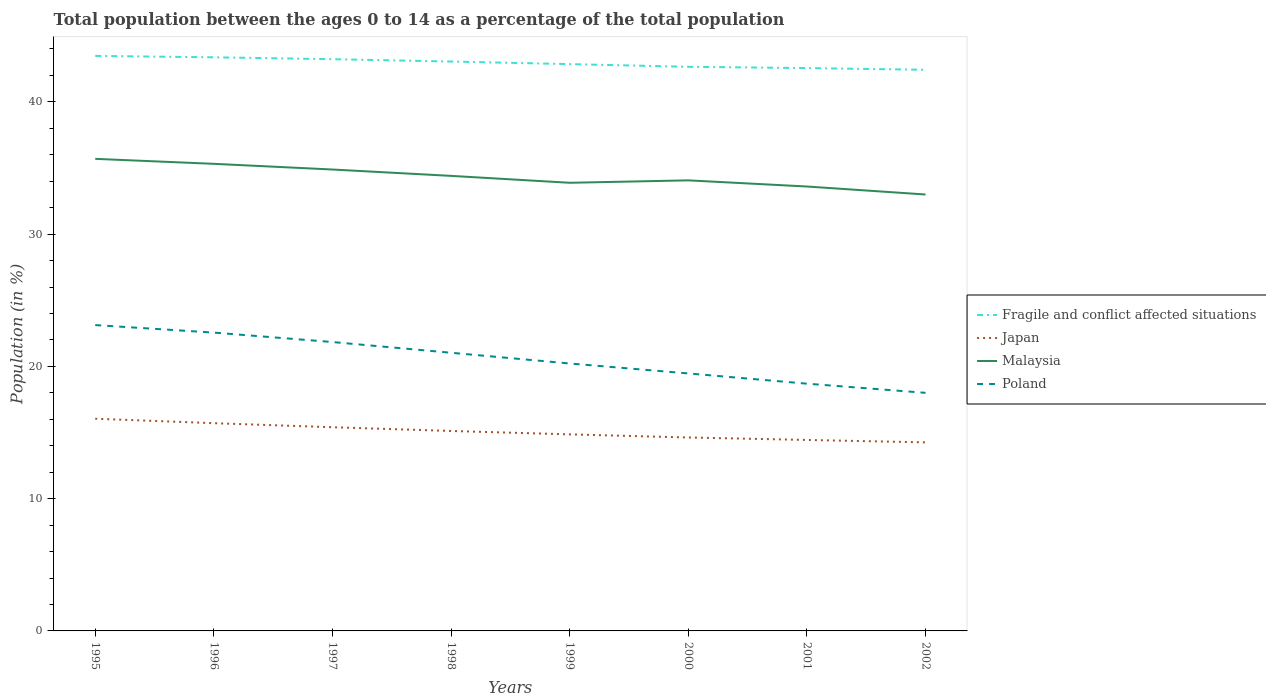How many different coloured lines are there?
Your answer should be compact. 4. Is the number of lines equal to the number of legend labels?
Provide a succinct answer. Yes. Across all years, what is the maximum percentage of the population ages 0 to 14 in Malaysia?
Make the answer very short. 32.99. In which year was the percentage of the population ages 0 to 14 in Japan maximum?
Your response must be concise. 2002. What is the total percentage of the population ages 0 to 14 in Japan in the graph?
Give a very brief answer. 1.79. What is the difference between the highest and the second highest percentage of the population ages 0 to 14 in Poland?
Your answer should be very brief. 5.12. What is the difference between the highest and the lowest percentage of the population ages 0 to 14 in Poland?
Ensure brevity in your answer.  4. Is the percentage of the population ages 0 to 14 in Fragile and conflict affected situations strictly greater than the percentage of the population ages 0 to 14 in Malaysia over the years?
Your answer should be very brief. No. What is the difference between two consecutive major ticks on the Y-axis?
Give a very brief answer. 10. Does the graph contain any zero values?
Offer a very short reply. No. How many legend labels are there?
Offer a terse response. 4. How are the legend labels stacked?
Make the answer very short. Vertical. What is the title of the graph?
Keep it short and to the point. Total population between the ages 0 to 14 as a percentage of the total population. What is the label or title of the Y-axis?
Your answer should be compact. Population (in %). What is the Population (in %) of Fragile and conflict affected situations in 1995?
Keep it short and to the point. 43.47. What is the Population (in %) in Japan in 1995?
Give a very brief answer. 16.04. What is the Population (in %) of Malaysia in 1995?
Offer a terse response. 35.69. What is the Population (in %) in Poland in 1995?
Offer a very short reply. 23.12. What is the Population (in %) in Fragile and conflict affected situations in 1996?
Your answer should be very brief. 43.37. What is the Population (in %) in Japan in 1996?
Make the answer very short. 15.71. What is the Population (in %) of Malaysia in 1996?
Provide a short and direct response. 35.31. What is the Population (in %) in Poland in 1996?
Offer a terse response. 22.55. What is the Population (in %) of Fragile and conflict affected situations in 1997?
Offer a very short reply. 43.22. What is the Population (in %) of Japan in 1997?
Offer a very short reply. 15.4. What is the Population (in %) in Malaysia in 1997?
Ensure brevity in your answer.  34.88. What is the Population (in %) of Poland in 1997?
Offer a terse response. 21.84. What is the Population (in %) of Fragile and conflict affected situations in 1998?
Provide a succinct answer. 43.05. What is the Population (in %) in Japan in 1998?
Keep it short and to the point. 15.12. What is the Population (in %) of Malaysia in 1998?
Make the answer very short. 34.4. What is the Population (in %) in Poland in 1998?
Keep it short and to the point. 21.03. What is the Population (in %) in Fragile and conflict affected situations in 1999?
Provide a short and direct response. 42.85. What is the Population (in %) of Japan in 1999?
Provide a succinct answer. 14.86. What is the Population (in %) of Malaysia in 1999?
Your answer should be very brief. 33.88. What is the Population (in %) in Poland in 1999?
Provide a succinct answer. 20.22. What is the Population (in %) of Fragile and conflict affected situations in 2000?
Provide a short and direct response. 42.65. What is the Population (in %) of Japan in 2000?
Your answer should be compact. 14.62. What is the Population (in %) of Malaysia in 2000?
Your answer should be compact. 34.06. What is the Population (in %) of Poland in 2000?
Give a very brief answer. 19.47. What is the Population (in %) of Fragile and conflict affected situations in 2001?
Offer a very short reply. 42.55. What is the Population (in %) in Japan in 2001?
Provide a short and direct response. 14.44. What is the Population (in %) of Malaysia in 2001?
Keep it short and to the point. 33.6. What is the Population (in %) of Poland in 2001?
Your answer should be compact. 18.69. What is the Population (in %) in Fragile and conflict affected situations in 2002?
Your response must be concise. 42.42. What is the Population (in %) in Japan in 2002?
Offer a very short reply. 14.26. What is the Population (in %) of Malaysia in 2002?
Make the answer very short. 32.99. What is the Population (in %) in Poland in 2002?
Provide a succinct answer. 18. Across all years, what is the maximum Population (in %) of Fragile and conflict affected situations?
Offer a very short reply. 43.47. Across all years, what is the maximum Population (in %) of Japan?
Your answer should be compact. 16.04. Across all years, what is the maximum Population (in %) in Malaysia?
Your answer should be compact. 35.69. Across all years, what is the maximum Population (in %) of Poland?
Give a very brief answer. 23.12. Across all years, what is the minimum Population (in %) of Fragile and conflict affected situations?
Your response must be concise. 42.42. Across all years, what is the minimum Population (in %) of Japan?
Your response must be concise. 14.26. Across all years, what is the minimum Population (in %) in Malaysia?
Your answer should be compact. 32.99. Across all years, what is the minimum Population (in %) of Poland?
Your response must be concise. 18. What is the total Population (in %) of Fragile and conflict affected situations in the graph?
Give a very brief answer. 343.58. What is the total Population (in %) in Japan in the graph?
Your answer should be very brief. 120.44. What is the total Population (in %) of Malaysia in the graph?
Offer a terse response. 274.82. What is the total Population (in %) of Poland in the graph?
Provide a succinct answer. 164.92. What is the difference between the Population (in %) of Fragile and conflict affected situations in 1995 and that in 1996?
Provide a succinct answer. 0.11. What is the difference between the Population (in %) of Japan in 1995 and that in 1996?
Your answer should be very brief. 0.34. What is the difference between the Population (in %) in Malaysia in 1995 and that in 1996?
Your answer should be compact. 0.38. What is the difference between the Population (in %) of Poland in 1995 and that in 1996?
Give a very brief answer. 0.57. What is the difference between the Population (in %) of Fragile and conflict affected situations in 1995 and that in 1997?
Make the answer very short. 0.25. What is the difference between the Population (in %) of Japan in 1995 and that in 1997?
Give a very brief answer. 0.64. What is the difference between the Population (in %) of Malaysia in 1995 and that in 1997?
Offer a very short reply. 0.81. What is the difference between the Population (in %) in Poland in 1995 and that in 1997?
Give a very brief answer. 1.28. What is the difference between the Population (in %) of Fragile and conflict affected situations in 1995 and that in 1998?
Keep it short and to the point. 0.43. What is the difference between the Population (in %) in Japan in 1995 and that in 1998?
Your answer should be very brief. 0.93. What is the difference between the Population (in %) in Malaysia in 1995 and that in 1998?
Offer a very short reply. 1.29. What is the difference between the Population (in %) of Poland in 1995 and that in 1998?
Your answer should be compact. 2.09. What is the difference between the Population (in %) of Fragile and conflict affected situations in 1995 and that in 1999?
Your answer should be very brief. 0.62. What is the difference between the Population (in %) of Japan in 1995 and that in 1999?
Provide a succinct answer. 1.18. What is the difference between the Population (in %) of Malaysia in 1995 and that in 1999?
Provide a succinct answer. 1.81. What is the difference between the Population (in %) in Poland in 1995 and that in 1999?
Your answer should be very brief. 2.9. What is the difference between the Population (in %) in Fragile and conflict affected situations in 1995 and that in 2000?
Ensure brevity in your answer.  0.82. What is the difference between the Population (in %) in Japan in 1995 and that in 2000?
Your response must be concise. 1.42. What is the difference between the Population (in %) in Malaysia in 1995 and that in 2000?
Provide a succinct answer. 1.63. What is the difference between the Population (in %) in Poland in 1995 and that in 2000?
Offer a very short reply. 3.66. What is the difference between the Population (in %) in Fragile and conflict affected situations in 1995 and that in 2001?
Offer a terse response. 0.92. What is the difference between the Population (in %) of Japan in 1995 and that in 2001?
Provide a short and direct response. 1.61. What is the difference between the Population (in %) of Malaysia in 1995 and that in 2001?
Your response must be concise. 2.09. What is the difference between the Population (in %) of Poland in 1995 and that in 2001?
Offer a terse response. 4.43. What is the difference between the Population (in %) of Fragile and conflict affected situations in 1995 and that in 2002?
Keep it short and to the point. 1.05. What is the difference between the Population (in %) in Japan in 1995 and that in 2002?
Offer a terse response. 1.79. What is the difference between the Population (in %) of Malaysia in 1995 and that in 2002?
Make the answer very short. 2.7. What is the difference between the Population (in %) in Poland in 1995 and that in 2002?
Your answer should be very brief. 5.12. What is the difference between the Population (in %) of Fragile and conflict affected situations in 1996 and that in 1997?
Provide a short and direct response. 0.14. What is the difference between the Population (in %) in Japan in 1996 and that in 1997?
Offer a terse response. 0.31. What is the difference between the Population (in %) of Malaysia in 1996 and that in 1997?
Your answer should be compact. 0.43. What is the difference between the Population (in %) in Poland in 1996 and that in 1997?
Keep it short and to the point. 0.71. What is the difference between the Population (in %) of Fragile and conflict affected situations in 1996 and that in 1998?
Offer a very short reply. 0.32. What is the difference between the Population (in %) in Japan in 1996 and that in 1998?
Your response must be concise. 0.59. What is the difference between the Population (in %) of Malaysia in 1996 and that in 1998?
Ensure brevity in your answer.  0.91. What is the difference between the Population (in %) in Poland in 1996 and that in 1998?
Your answer should be very brief. 1.52. What is the difference between the Population (in %) of Fragile and conflict affected situations in 1996 and that in 1999?
Provide a succinct answer. 0.52. What is the difference between the Population (in %) in Japan in 1996 and that in 1999?
Offer a terse response. 0.85. What is the difference between the Population (in %) of Malaysia in 1996 and that in 1999?
Offer a terse response. 1.43. What is the difference between the Population (in %) in Poland in 1996 and that in 1999?
Offer a very short reply. 2.33. What is the difference between the Population (in %) of Fragile and conflict affected situations in 1996 and that in 2000?
Make the answer very short. 0.72. What is the difference between the Population (in %) of Japan in 1996 and that in 2000?
Make the answer very short. 1.08. What is the difference between the Population (in %) of Malaysia in 1996 and that in 2000?
Offer a very short reply. 1.25. What is the difference between the Population (in %) of Poland in 1996 and that in 2000?
Your answer should be compact. 3.09. What is the difference between the Population (in %) of Fragile and conflict affected situations in 1996 and that in 2001?
Provide a short and direct response. 0.82. What is the difference between the Population (in %) of Japan in 1996 and that in 2001?
Keep it short and to the point. 1.27. What is the difference between the Population (in %) in Malaysia in 1996 and that in 2001?
Keep it short and to the point. 1.71. What is the difference between the Population (in %) of Poland in 1996 and that in 2001?
Make the answer very short. 3.86. What is the difference between the Population (in %) in Fragile and conflict affected situations in 1996 and that in 2002?
Give a very brief answer. 0.94. What is the difference between the Population (in %) of Japan in 1996 and that in 2002?
Offer a terse response. 1.45. What is the difference between the Population (in %) in Malaysia in 1996 and that in 2002?
Offer a very short reply. 2.32. What is the difference between the Population (in %) of Poland in 1996 and that in 2002?
Your answer should be very brief. 4.55. What is the difference between the Population (in %) in Fragile and conflict affected situations in 1997 and that in 1998?
Provide a succinct answer. 0.18. What is the difference between the Population (in %) of Japan in 1997 and that in 1998?
Give a very brief answer. 0.28. What is the difference between the Population (in %) in Malaysia in 1997 and that in 1998?
Offer a terse response. 0.48. What is the difference between the Population (in %) in Poland in 1997 and that in 1998?
Your answer should be very brief. 0.81. What is the difference between the Population (in %) of Fragile and conflict affected situations in 1997 and that in 1999?
Your answer should be compact. 0.37. What is the difference between the Population (in %) in Japan in 1997 and that in 1999?
Your response must be concise. 0.54. What is the difference between the Population (in %) of Malaysia in 1997 and that in 1999?
Offer a terse response. 1. What is the difference between the Population (in %) of Poland in 1997 and that in 1999?
Your answer should be compact. 1.62. What is the difference between the Population (in %) of Fragile and conflict affected situations in 1997 and that in 2000?
Keep it short and to the point. 0.58. What is the difference between the Population (in %) of Japan in 1997 and that in 2000?
Your answer should be very brief. 0.78. What is the difference between the Population (in %) of Malaysia in 1997 and that in 2000?
Your response must be concise. 0.82. What is the difference between the Population (in %) in Poland in 1997 and that in 2000?
Provide a short and direct response. 2.37. What is the difference between the Population (in %) of Fragile and conflict affected situations in 1997 and that in 2001?
Your answer should be compact. 0.67. What is the difference between the Population (in %) of Japan in 1997 and that in 2001?
Provide a short and direct response. 0.96. What is the difference between the Population (in %) in Malaysia in 1997 and that in 2001?
Give a very brief answer. 1.28. What is the difference between the Population (in %) in Poland in 1997 and that in 2001?
Offer a very short reply. 3.15. What is the difference between the Population (in %) of Fragile and conflict affected situations in 1997 and that in 2002?
Your answer should be very brief. 0.8. What is the difference between the Population (in %) of Japan in 1997 and that in 2002?
Make the answer very short. 1.14. What is the difference between the Population (in %) of Malaysia in 1997 and that in 2002?
Your response must be concise. 1.89. What is the difference between the Population (in %) in Poland in 1997 and that in 2002?
Provide a succinct answer. 3.84. What is the difference between the Population (in %) of Fragile and conflict affected situations in 1998 and that in 1999?
Your answer should be compact. 0.2. What is the difference between the Population (in %) in Japan in 1998 and that in 1999?
Offer a very short reply. 0.26. What is the difference between the Population (in %) of Malaysia in 1998 and that in 1999?
Your answer should be very brief. 0.52. What is the difference between the Population (in %) in Poland in 1998 and that in 1999?
Provide a short and direct response. 0.81. What is the difference between the Population (in %) in Fragile and conflict affected situations in 1998 and that in 2000?
Provide a succinct answer. 0.4. What is the difference between the Population (in %) of Japan in 1998 and that in 2000?
Provide a short and direct response. 0.49. What is the difference between the Population (in %) of Malaysia in 1998 and that in 2000?
Your answer should be very brief. 0.34. What is the difference between the Population (in %) in Poland in 1998 and that in 2000?
Ensure brevity in your answer.  1.56. What is the difference between the Population (in %) of Fragile and conflict affected situations in 1998 and that in 2001?
Keep it short and to the point. 0.5. What is the difference between the Population (in %) in Japan in 1998 and that in 2001?
Keep it short and to the point. 0.68. What is the difference between the Population (in %) of Malaysia in 1998 and that in 2001?
Provide a succinct answer. 0.8. What is the difference between the Population (in %) of Poland in 1998 and that in 2001?
Provide a succinct answer. 2.34. What is the difference between the Population (in %) in Fragile and conflict affected situations in 1998 and that in 2002?
Make the answer very short. 0.63. What is the difference between the Population (in %) of Japan in 1998 and that in 2002?
Offer a terse response. 0.86. What is the difference between the Population (in %) of Malaysia in 1998 and that in 2002?
Give a very brief answer. 1.41. What is the difference between the Population (in %) of Poland in 1998 and that in 2002?
Provide a succinct answer. 3.03. What is the difference between the Population (in %) of Fragile and conflict affected situations in 1999 and that in 2000?
Provide a succinct answer. 0.2. What is the difference between the Population (in %) in Japan in 1999 and that in 2000?
Provide a succinct answer. 0.23. What is the difference between the Population (in %) in Malaysia in 1999 and that in 2000?
Offer a terse response. -0.18. What is the difference between the Population (in %) of Poland in 1999 and that in 2000?
Ensure brevity in your answer.  0.75. What is the difference between the Population (in %) of Fragile and conflict affected situations in 1999 and that in 2001?
Provide a succinct answer. 0.3. What is the difference between the Population (in %) of Japan in 1999 and that in 2001?
Make the answer very short. 0.42. What is the difference between the Population (in %) in Malaysia in 1999 and that in 2001?
Your response must be concise. 0.28. What is the difference between the Population (in %) in Poland in 1999 and that in 2001?
Ensure brevity in your answer.  1.53. What is the difference between the Population (in %) in Fragile and conflict affected situations in 1999 and that in 2002?
Provide a succinct answer. 0.43. What is the difference between the Population (in %) in Japan in 1999 and that in 2002?
Your response must be concise. 0.6. What is the difference between the Population (in %) of Malaysia in 1999 and that in 2002?
Make the answer very short. 0.89. What is the difference between the Population (in %) of Poland in 1999 and that in 2002?
Ensure brevity in your answer.  2.22. What is the difference between the Population (in %) of Fragile and conflict affected situations in 2000 and that in 2001?
Offer a terse response. 0.1. What is the difference between the Population (in %) of Japan in 2000 and that in 2001?
Offer a terse response. 0.19. What is the difference between the Population (in %) in Malaysia in 2000 and that in 2001?
Provide a short and direct response. 0.47. What is the difference between the Population (in %) in Poland in 2000 and that in 2001?
Provide a succinct answer. 0.77. What is the difference between the Population (in %) in Fragile and conflict affected situations in 2000 and that in 2002?
Ensure brevity in your answer.  0.23. What is the difference between the Population (in %) in Japan in 2000 and that in 2002?
Offer a terse response. 0.37. What is the difference between the Population (in %) of Malaysia in 2000 and that in 2002?
Offer a very short reply. 1.07. What is the difference between the Population (in %) in Poland in 2000 and that in 2002?
Make the answer very short. 1.47. What is the difference between the Population (in %) of Fragile and conflict affected situations in 2001 and that in 2002?
Give a very brief answer. 0.13. What is the difference between the Population (in %) of Japan in 2001 and that in 2002?
Ensure brevity in your answer.  0.18. What is the difference between the Population (in %) in Malaysia in 2001 and that in 2002?
Offer a terse response. 0.6. What is the difference between the Population (in %) of Poland in 2001 and that in 2002?
Your response must be concise. 0.69. What is the difference between the Population (in %) in Fragile and conflict affected situations in 1995 and the Population (in %) in Japan in 1996?
Make the answer very short. 27.77. What is the difference between the Population (in %) in Fragile and conflict affected situations in 1995 and the Population (in %) in Malaysia in 1996?
Give a very brief answer. 8.16. What is the difference between the Population (in %) in Fragile and conflict affected situations in 1995 and the Population (in %) in Poland in 1996?
Your response must be concise. 20.92. What is the difference between the Population (in %) of Japan in 1995 and the Population (in %) of Malaysia in 1996?
Make the answer very short. -19.27. What is the difference between the Population (in %) in Japan in 1995 and the Population (in %) in Poland in 1996?
Provide a short and direct response. -6.51. What is the difference between the Population (in %) in Malaysia in 1995 and the Population (in %) in Poland in 1996?
Offer a terse response. 13.14. What is the difference between the Population (in %) of Fragile and conflict affected situations in 1995 and the Population (in %) of Japan in 1997?
Make the answer very short. 28.07. What is the difference between the Population (in %) in Fragile and conflict affected situations in 1995 and the Population (in %) in Malaysia in 1997?
Your response must be concise. 8.59. What is the difference between the Population (in %) in Fragile and conflict affected situations in 1995 and the Population (in %) in Poland in 1997?
Ensure brevity in your answer.  21.63. What is the difference between the Population (in %) of Japan in 1995 and the Population (in %) of Malaysia in 1997?
Ensure brevity in your answer.  -18.84. What is the difference between the Population (in %) in Japan in 1995 and the Population (in %) in Poland in 1997?
Offer a very short reply. -5.8. What is the difference between the Population (in %) of Malaysia in 1995 and the Population (in %) of Poland in 1997?
Keep it short and to the point. 13.85. What is the difference between the Population (in %) in Fragile and conflict affected situations in 1995 and the Population (in %) in Japan in 1998?
Make the answer very short. 28.36. What is the difference between the Population (in %) of Fragile and conflict affected situations in 1995 and the Population (in %) of Malaysia in 1998?
Provide a short and direct response. 9.07. What is the difference between the Population (in %) of Fragile and conflict affected situations in 1995 and the Population (in %) of Poland in 1998?
Give a very brief answer. 22.44. What is the difference between the Population (in %) of Japan in 1995 and the Population (in %) of Malaysia in 1998?
Make the answer very short. -18.36. What is the difference between the Population (in %) of Japan in 1995 and the Population (in %) of Poland in 1998?
Provide a succinct answer. -4.99. What is the difference between the Population (in %) of Malaysia in 1995 and the Population (in %) of Poland in 1998?
Give a very brief answer. 14.66. What is the difference between the Population (in %) of Fragile and conflict affected situations in 1995 and the Population (in %) of Japan in 1999?
Keep it short and to the point. 28.61. What is the difference between the Population (in %) in Fragile and conflict affected situations in 1995 and the Population (in %) in Malaysia in 1999?
Offer a very short reply. 9.59. What is the difference between the Population (in %) of Fragile and conflict affected situations in 1995 and the Population (in %) of Poland in 1999?
Offer a terse response. 23.25. What is the difference between the Population (in %) in Japan in 1995 and the Population (in %) in Malaysia in 1999?
Your answer should be very brief. -17.84. What is the difference between the Population (in %) in Japan in 1995 and the Population (in %) in Poland in 1999?
Your response must be concise. -4.18. What is the difference between the Population (in %) in Malaysia in 1995 and the Population (in %) in Poland in 1999?
Offer a very short reply. 15.47. What is the difference between the Population (in %) of Fragile and conflict affected situations in 1995 and the Population (in %) of Japan in 2000?
Ensure brevity in your answer.  28.85. What is the difference between the Population (in %) in Fragile and conflict affected situations in 1995 and the Population (in %) in Malaysia in 2000?
Give a very brief answer. 9.41. What is the difference between the Population (in %) of Fragile and conflict affected situations in 1995 and the Population (in %) of Poland in 2000?
Give a very brief answer. 24.01. What is the difference between the Population (in %) in Japan in 1995 and the Population (in %) in Malaysia in 2000?
Your response must be concise. -18.02. What is the difference between the Population (in %) of Japan in 1995 and the Population (in %) of Poland in 2000?
Provide a succinct answer. -3.42. What is the difference between the Population (in %) in Malaysia in 1995 and the Population (in %) in Poland in 2000?
Offer a very short reply. 16.22. What is the difference between the Population (in %) of Fragile and conflict affected situations in 1995 and the Population (in %) of Japan in 2001?
Your response must be concise. 29.03. What is the difference between the Population (in %) of Fragile and conflict affected situations in 1995 and the Population (in %) of Malaysia in 2001?
Make the answer very short. 9.87. What is the difference between the Population (in %) of Fragile and conflict affected situations in 1995 and the Population (in %) of Poland in 2001?
Provide a short and direct response. 24.78. What is the difference between the Population (in %) of Japan in 1995 and the Population (in %) of Malaysia in 2001?
Your response must be concise. -17.56. What is the difference between the Population (in %) of Japan in 1995 and the Population (in %) of Poland in 2001?
Keep it short and to the point. -2.65. What is the difference between the Population (in %) of Malaysia in 1995 and the Population (in %) of Poland in 2001?
Ensure brevity in your answer.  17. What is the difference between the Population (in %) of Fragile and conflict affected situations in 1995 and the Population (in %) of Japan in 2002?
Provide a short and direct response. 29.22. What is the difference between the Population (in %) of Fragile and conflict affected situations in 1995 and the Population (in %) of Malaysia in 2002?
Offer a very short reply. 10.48. What is the difference between the Population (in %) of Fragile and conflict affected situations in 1995 and the Population (in %) of Poland in 2002?
Keep it short and to the point. 25.47. What is the difference between the Population (in %) in Japan in 1995 and the Population (in %) in Malaysia in 2002?
Provide a short and direct response. -16.95. What is the difference between the Population (in %) of Japan in 1995 and the Population (in %) of Poland in 2002?
Offer a very short reply. -1.96. What is the difference between the Population (in %) of Malaysia in 1995 and the Population (in %) of Poland in 2002?
Your answer should be compact. 17.69. What is the difference between the Population (in %) of Fragile and conflict affected situations in 1996 and the Population (in %) of Japan in 1997?
Provide a succinct answer. 27.97. What is the difference between the Population (in %) in Fragile and conflict affected situations in 1996 and the Population (in %) in Malaysia in 1997?
Offer a very short reply. 8.48. What is the difference between the Population (in %) of Fragile and conflict affected situations in 1996 and the Population (in %) of Poland in 1997?
Offer a very short reply. 21.53. What is the difference between the Population (in %) in Japan in 1996 and the Population (in %) in Malaysia in 1997?
Your answer should be compact. -19.18. What is the difference between the Population (in %) of Japan in 1996 and the Population (in %) of Poland in 1997?
Your response must be concise. -6.13. What is the difference between the Population (in %) of Malaysia in 1996 and the Population (in %) of Poland in 1997?
Keep it short and to the point. 13.47. What is the difference between the Population (in %) of Fragile and conflict affected situations in 1996 and the Population (in %) of Japan in 1998?
Ensure brevity in your answer.  28.25. What is the difference between the Population (in %) of Fragile and conflict affected situations in 1996 and the Population (in %) of Malaysia in 1998?
Your answer should be very brief. 8.96. What is the difference between the Population (in %) in Fragile and conflict affected situations in 1996 and the Population (in %) in Poland in 1998?
Give a very brief answer. 22.34. What is the difference between the Population (in %) in Japan in 1996 and the Population (in %) in Malaysia in 1998?
Your response must be concise. -18.7. What is the difference between the Population (in %) of Japan in 1996 and the Population (in %) of Poland in 1998?
Keep it short and to the point. -5.32. What is the difference between the Population (in %) in Malaysia in 1996 and the Population (in %) in Poland in 1998?
Your answer should be compact. 14.28. What is the difference between the Population (in %) of Fragile and conflict affected situations in 1996 and the Population (in %) of Japan in 1999?
Provide a short and direct response. 28.51. What is the difference between the Population (in %) of Fragile and conflict affected situations in 1996 and the Population (in %) of Malaysia in 1999?
Offer a terse response. 9.49. What is the difference between the Population (in %) in Fragile and conflict affected situations in 1996 and the Population (in %) in Poland in 1999?
Ensure brevity in your answer.  23.15. What is the difference between the Population (in %) in Japan in 1996 and the Population (in %) in Malaysia in 1999?
Keep it short and to the point. -18.17. What is the difference between the Population (in %) in Japan in 1996 and the Population (in %) in Poland in 1999?
Ensure brevity in your answer.  -4.51. What is the difference between the Population (in %) in Malaysia in 1996 and the Population (in %) in Poland in 1999?
Make the answer very short. 15.09. What is the difference between the Population (in %) of Fragile and conflict affected situations in 1996 and the Population (in %) of Japan in 2000?
Your answer should be compact. 28.74. What is the difference between the Population (in %) of Fragile and conflict affected situations in 1996 and the Population (in %) of Malaysia in 2000?
Your answer should be compact. 9.3. What is the difference between the Population (in %) of Fragile and conflict affected situations in 1996 and the Population (in %) of Poland in 2000?
Ensure brevity in your answer.  23.9. What is the difference between the Population (in %) in Japan in 1996 and the Population (in %) in Malaysia in 2000?
Give a very brief answer. -18.36. What is the difference between the Population (in %) of Japan in 1996 and the Population (in %) of Poland in 2000?
Offer a terse response. -3.76. What is the difference between the Population (in %) of Malaysia in 1996 and the Population (in %) of Poland in 2000?
Provide a short and direct response. 15.85. What is the difference between the Population (in %) in Fragile and conflict affected situations in 1996 and the Population (in %) in Japan in 2001?
Your answer should be very brief. 28.93. What is the difference between the Population (in %) of Fragile and conflict affected situations in 1996 and the Population (in %) of Malaysia in 2001?
Keep it short and to the point. 9.77. What is the difference between the Population (in %) in Fragile and conflict affected situations in 1996 and the Population (in %) in Poland in 2001?
Ensure brevity in your answer.  24.67. What is the difference between the Population (in %) of Japan in 1996 and the Population (in %) of Malaysia in 2001?
Keep it short and to the point. -17.89. What is the difference between the Population (in %) in Japan in 1996 and the Population (in %) in Poland in 2001?
Make the answer very short. -2.99. What is the difference between the Population (in %) of Malaysia in 1996 and the Population (in %) of Poland in 2001?
Keep it short and to the point. 16.62. What is the difference between the Population (in %) of Fragile and conflict affected situations in 1996 and the Population (in %) of Japan in 2002?
Ensure brevity in your answer.  29.11. What is the difference between the Population (in %) of Fragile and conflict affected situations in 1996 and the Population (in %) of Malaysia in 2002?
Give a very brief answer. 10.37. What is the difference between the Population (in %) of Fragile and conflict affected situations in 1996 and the Population (in %) of Poland in 2002?
Offer a terse response. 25.37. What is the difference between the Population (in %) in Japan in 1996 and the Population (in %) in Malaysia in 2002?
Your answer should be very brief. -17.29. What is the difference between the Population (in %) in Japan in 1996 and the Population (in %) in Poland in 2002?
Ensure brevity in your answer.  -2.29. What is the difference between the Population (in %) of Malaysia in 1996 and the Population (in %) of Poland in 2002?
Offer a very short reply. 17.31. What is the difference between the Population (in %) in Fragile and conflict affected situations in 1997 and the Population (in %) in Japan in 1998?
Your response must be concise. 28.11. What is the difference between the Population (in %) in Fragile and conflict affected situations in 1997 and the Population (in %) in Malaysia in 1998?
Keep it short and to the point. 8.82. What is the difference between the Population (in %) of Fragile and conflict affected situations in 1997 and the Population (in %) of Poland in 1998?
Your response must be concise. 22.19. What is the difference between the Population (in %) in Japan in 1997 and the Population (in %) in Malaysia in 1998?
Keep it short and to the point. -19. What is the difference between the Population (in %) of Japan in 1997 and the Population (in %) of Poland in 1998?
Keep it short and to the point. -5.63. What is the difference between the Population (in %) of Malaysia in 1997 and the Population (in %) of Poland in 1998?
Ensure brevity in your answer.  13.85. What is the difference between the Population (in %) of Fragile and conflict affected situations in 1997 and the Population (in %) of Japan in 1999?
Make the answer very short. 28.37. What is the difference between the Population (in %) in Fragile and conflict affected situations in 1997 and the Population (in %) in Malaysia in 1999?
Provide a short and direct response. 9.34. What is the difference between the Population (in %) in Fragile and conflict affected situations in 1997 and the Population (in %) in Poland in 1999?
Make the answer very short. 23. What is the difference between the Population (in %) in Japan in 1997 and the Population (in %) in Malaysia in 1999?
Provide a succinct answer. -18.48. What is the difference between the Population (in %) of Japan in 1997 and the Population (in %) of Poland in 1999?
Ensure brevity in your answer.  -4.82. What is the difference between the Population (in %) of Malaysia in 1997 and the Population (in %) of Poland in 1999?
Ensure brevity in your answer.  14.66. What is the difference between the Population (in %) of Fragile and conflict affected situations in 1997 and the Population (in %) of Japan in 2000?
Give a very brief answer. 28.6. What is the difference between the Population (in %) in Fragile and conflict affected situations in 1997 and the Population (in %) in Malaysia in 2000?
Provide a succinct answer. 9.16. What is the difference between the Population (in %) of Fragile and conflict affected situations in 1997 and the Population (in %) of Poland in 2000?
Provide a succinct answer. 23.76. What is the difference between the Population (in %) in Japan in 1997 and the Population (in %) in Malaysia in 2000?
Offer a terse response. -18.66. What is the difference between the Population (in %) in Japan in 1997 and the Population (in %) in Poland in 2000?
Provide a succinct answer. -4.07. What is the difference between the Population (in %) of Malaysia in 1997 and the Population (in %) of Poland in 2000?
Offer a very short reply. 15.42. What is the difference between the Population (in %) in Fragile and conflict affected situations in 1997 and the Population (in %) in Japan in 2001?
Ensure brevity in your answer.  28.79. What is the difference between the Population (in %) in Fragile and conflict affected situations in 1997 and the Population (in %) in Malaysia in 2001?
Your answer should be very brief. 9.62. What is the difference between the Population (in %) in Fragile and conflict affected situations in 1997 and the Population (in %) in Poland in 2001?
Your answer should be compact. 24.53. What is the difference between the Population (in %) in Japan in 1997 and the Population (in %) in Malaysia in 2001?
Ensure brevity in your answer.  -18.2. What is the difference between the Population (in %) of Japan in 1997 and the Population (in %) of Poland in 2001?
Provide a short and direct response. -3.29. What is the difference between the Population (in %) of Malaysia in 1997 and the Population (in %) of Poland in 2001?
Give a very brief answer. 16.19. What is the difference between the Population (in %) of Fragile and conflict affected situations in 1997 and the Population (in %) of Japan in 2002?
Offer a terse response. 28.97. What is the difference between the Population (in %) of Fragile and conflict affected situations in 1997 and the Population (in %) of Malaysia in 2002?
Keep it short and to the point. 10.23. What is the difference between the Population (in %) in Fragile and conflict affected situations in 1997 and the Population (in %) in Poland in 2002?
Provide a short and direct response. 25.22. What is the difference between the Population (in %) of Japan in 1997 and the Population (in %) of Malaysia in 2002?
Ensure brevity in your answer.  -17.59. What is the difference between the Population (in %) in Japan in 1997 and the Population (in %) in Poland in 2002?
Keep it short and to the point. -2.6. What is the difference between the Population (in %) in Malaysia in 1997 and the Population (in %) in Poland in 2002?
Give a very brief answer. 16.88. What is the difference between the Population (in %) of Fragile and conflict affected situations in 1998 and the Population (in %) of Japan in 1999?
Offer a terse response. 28.19. What is the difference between the Population (in %) in Fragile and conflict affected situations in 1998 and the Population (in %) in Malaysia in 1999?
Your answer should be very brief. 9.17. What is the difference between the Population (in %) in Fragile and conflict affected situations in 1998 and the Population (in %) in Poland in 1999?
Provide a short and direct response. 22.83. What is the difference between the Population (in %) in Japan in 1998 and the Population (in %) in Malaysia in 1999?
Your answer should be compact. -18.76. What is the difference between the Population (in %) of Japan in 1998 and the Population (in %) of Poland in 1999?
Keep it short and to the point. -5.1. What is the difference between the Population (in %) of Malaysia in 1998 and the Population (in %) of Poland in 1999?
Your response must be concise. 14.18. What is the difference between the Population (in %) of Fragile and conflict affected situations in 1998 and the Population (in %) of Japan in 2000?
Offer a very short reply. 28.42. What is the difference between the Population (in %) of Fragile and conflict affected situations in 1998 and the Population (in %) of Malaysia in 2000?
Provide a short and direct response. 8.98. What is the difference between the Population (in %) of Fragile and conflict affected situations in 1998 and the Population (in %) of Poland in 2000?
Ensure brevity in your answer.  23.58. What is the difference between the Population (in %) in Japan in 1998 and the Population (in %) in Malaysia in 2000?
Your response must be concise. -18.95. What is the difference between the Population (in %) in Japan in 1998 and the Population (in %) in Poland in 2000?
Your answer should be very brief. -4.35. What is the difference between the Population (in %) of Malaysia in 1998 and the Population (in %) of Poland in 2000?
Ensure brevity in your answer.  14.94. What is the difference between the Population (in %) in Fragile and conflict affected situations in 1998 and the Population (in %) in Japan in 2001?
Your answer should be compact. 28.61. What is the difference between the Population (in %) of Fragile and conflict affected situations in 1998 and the Population (in %) of Malaysia in 2001?
Give a very brief answer. 9.45. What is the difference between the Population (in %) of Fragile and conflict affected situations in 1998 and the Population (in %) of Poland in 2001?
Your answer should be very brief. 24.35. What is the difference between the Population (in %) of Japan in 1998 and the Population (in %) of Malaysia in 2001?
Provide a succinct answer. -18.48. What is the difference between the Population (in %) in Japan in 1998 and the Population (in %) in Poland in 2001?
Provide a short and direct response. -3.58. What is the difference between the Population (in %) of Malaysia in 1998 and the Population (in %) of Poland in 2001?
Your answer should be very brief. 15.71. What is the difference between the Population (in %) in Fragile and conflict affected situations in 1998 and the Population (in %) in Japan in 2002?
Your answer should be compact. 28.79. What is the difference between the Population (in %) of Fragile and conflict affected situations in 1998 and the Population (in %) of Malaysia in 2002?
Provide a short and direct response. 10.05. What is the difference between the Population (in %) of Fragile and conflict affected situations in 1998 and the Population (in %) of Poland in 2002?
Keep it short and to the point. 25.05. What is the difference between the Population (in %) of Japan in 1998 and the Population (in %) of Malaysia in 2002?
Provide a short and direct response. -17.88. What is the difference between the Population (in %) of Japan in 1998 and the Population (in %) of Poland in 2002?
Keep it short and to the point. -2.88. What is the difference between the Population (in %) of Malaysia in 1998 and the Population (in %) of Poland in 2002?
Your response must be concise. 16.4. What is the difference between the Population (in %) in Fragile and conflict affected situations in 1999 and the Population (in %) in Japan in 2000?
Your answer should be compact. 28.23. What is the difference between the Population (in %) in Fragile and conflict affected situations in 1999 and the Population (in %) in Malaysia in 2000?
Make the answer very short. 8.79. What is the difference between the Population (in %) of Fragile and conflict affected situations in 1999 and the Population (in %) of Poland in 2000?
Provide a short and direct response. 23.38. What is the difference between the Population (in %) of Japan in 1999 and the Population (in %) of Malaysia in 2000?
Offer a very short reply. -19.21. What is the difference between the Population (in %) of Japan in 1999 and the Population (in %) of Poland in 2000?
Offer a terse response. -4.61. What is the difference between the Population (in %) of Malaysia in 1999 and the Population (in %) of Poland in 2000?
Give a very brief answer. 14.41. What is the difference between the Population (in %) in Fragile and conflict affected situations in 1999 and the Population (in %) in Japan in 2001?
Provide a succinct answer. 28.41. What is the difference between the Population (in %) in Fragile and conflict affected situations in 1999 and the Population (in %) in Malaysia in 2001?
Provide a succinct answer. 9.25. What is the difference between the Population (in %) in Fragile and conflict affected situations in 1999 and the Population (in %) in Poland in 2001?
Your answer should be very brief. 24.16. What is the difference between the Population (in %) of Japan in 1999 and the Population (in %) of Malaysia in 2001?
Your answer should be very brief. -18.74. What is the difference between the Population (in %) of Japan in 1999 and the Population (in %) of Poland in 2001?
Your answer should be very brief. -3.83. What is the difference between the Population (in %) of Malaysia in 1999 and the Population (in %) of Poland in 2001?
Provide a short and direct response. 15.19. What is the difference between the Population (in %) in Fragile and conflict affected situations in 1999 and the Population (in %) in Japan in 2002?
Make the answer very short. 28.6. What is the difference between the Population (in %) in Fragile and conflict affected situations in 1999 and the Population (in %) in Malaysia in 2002?
Provide a succinct answer. 9.86. What is the difference between the Population (in %) in Fragile and conflict affected situations in 1999 and the Population (in %) in Poland in 2002?
Provide a short and direct response. 24.85. What is the difference between the Population (in %) in Japan in 1999 and the Population (in %) in Malaysia in 2002?
Give a very brief answer. -18.14. What is the difference between the Population (in %) of Japan in 1999 and the Population (in %) of Poland in 2002?
Make the answer very short. -3.14. What is the difference between the Population (in %) in Malaysia in 1999 and the Population (in %) in Poland in 2002?
Make the answer very short. 15.88. What is the difference between the Population (in %) in Fragile and conflict affected situations in 2000 and the Population (in %) in Japan in 2001?
Your answer should be very brief. 28.21. What is the difference between the Population (in %) of Fragile and conflict affected situations in 2000 and the Population (in %) of Malaysia in 2001?
Make the answer very short. 9.05. What is the difference between the Population (in %) of Fragile and conflict affected situations in 2000 and the Population (in %) of Poland in 2001?
Offer a terse response. 23.96. What is the difference between the Population (in %) of Japan in 2000 and the Population (in %) of Malaysia in 2001?
Offer a very short reply. -18.97. What is the difference between the Population (in %) in Japan in 2000 and the Population (in %) in Poland in 2001?
Your response must be concise. -4.07. What is the difference between the Population (in %) of Malaysia in 2000 and the Population (in %) of Poland in 2001?
Ensure brevity in your answer.  15.37. What is the difference between the Population (in %) in Fragile and conflict affected situations in 2000 and the Population (in %) in Japan in 2002?
Give a very brief answer. 28.39. What is the difference between the Population (in %) of Fragile and conflict affected situations in 2000 and the Population (in %) of Malaysia in 2002?
Give a very brief answer. 9.65. What is the difference between the Population (in %) in Fragile and conflict affected situations in 2000 and the Population (in %) in Poland in 2002?
Provide a short and direct response. 24.65. What is the difference between the Population (in %) in Japan in 2000 and the Population (in %) in Malaysia in 2002?
Offer a terse response. -18.37. What is the difference between the Population (in %) of Japan in 2000 and the Population (in %) of Poland in 2002?
Ensure brevity in your answer.  -3.38. What is the difference between the Population (in %) of Malaysia in 2000 and the Population (in %) of Poland in 2002?
Ensure brevity in your answer.  16.06. What is the difference between the Population (in %) of Fragile and conflict affected situations in 2001 and the Population (in %) of Japan in 2002?
Provide a short and direct response. 28.3. What is the difference between the Population (in %) of Fragile and conflict affected situations in 2001 and the Population (in %) of Malaysia in 2002?
Your response must be concise. 9.56. What is the difference between the Population (in %) in Fragile and conflict affected situations in 2001 and the Population (in %) in Poland in 2002?
Offer a very short reply. 24.55. What is the difference between the Population (in %) of Japan in 2001 and the Population (in %) of Malaysia in 2002?
Ensure brevity in your answer.  -18.56. What is the difference between the Population (in %) in Japan in 2001 and the Population (in %) in Poland in 2002?
Your response must be concise. -3.56. What is the difference between the Population (in %) of Malaysia in 2001 and the Population (in %) of Poland in 2002?
Your answer should be compact. 15.6. What is the average Population (in %) in Fragile and conflict affected situations per year?
Your response must be concise. 42.95. What is the average Population (in %) of Japan per year?
Your response must be concise. 15.05. What is the average Population (in %) of Malaysia per year?
Your answer should be compact. 34.35. What is the average Population (in %) of Poland per year?
Make the answer very short. 20.62. In the year 1995, what is the difference between the Population (in %) in Fragile and conflict affected situations and Population (in %) in Japan?
Offer a very short reply. 27.43. In the year 1995, what is the difference between the Population (in %) in Fragile and conflict affected situations and Population (in %) in Malaysia?
Give a very brief answer. 7.78. In the year 1995, what is the difference between the Population (in %) in Fragile and conflict affected situations and Population (in %) in Poland?
Offer a terse response. 20.35. In the year 1995, what is the difference between the Population (in %) of Japan and Population (in %) of Malaysia?
Offer a very short reply. -19.65. In the year 1995, what is the difference between the Population (in %) of Japan and Population (in %) of Poland?
Make the answer very short. -7.08. In the year 1995, what is the difference between the Population (in %) in Malaysia and Population (in %) in Poland?
Your response must be concise. 12.57. In the year 1996, what is the difference between the Population (in %) in Fragile and conflict affected situations and Population (in %) in Japan?
Your answer should be compact. 27.66. In the year 1996, what is the difference between the Population (in %) of Fragile and conflict affected situations and Population (in %) of Malaysia?
Your answer should be compact. 8.05. In the year 1996, what is the difference between the Population (in %) in Fragile and conflict affected situations and Population (in %) in Poland?
Give a very brief answer. 20.81. In the year 1996, what is the difference between the Population (in %) of Japan and Population (in %) of Malaysia?
Your answer should be very brief. -19.61. In the year 1996, what is the difference between the Population (in %) of Japan and Population (in %) of Poland?
Provide a short and direct response. -6.85. In the year 1996, what is the difference between the Population (in %) in Malaysia and Population (in %) in Poland?
Offer a terse response. 12.76. In the year 1997, what is the difference between the Population (in %) of Fragile and conflict affected situations and Population (in %) of Japan?
Offer a terse response. 27.82. In the year 1997, what is the difference between the Population (in %) in Fragile and conflict affected situations and Population (in %) in Malaysia?
Your answer should be compact. 8.34. In the year 1997, what is the difference between the Population (in %) in Fragile and conflict affected situations and Population (in %) in Poland?
Ensure brevity in your answer.  21.38. In the year 1997, what is the difference between the Population (in %) in Japan and Population (in %) in Malaysia?
Your answer should be very brief. -19.48. In the year 1997, what is the difference between the Population (in %) of Japan and Population (in %) of Poland?
Offer a terse response. -6.44. In the year 1997, what is the difference between the Population (in %) of Malaysia and Population (in %) of Poland?
Ensure brevity in your answer.  13.04. In the year 1998, what is the difference between the Population (in %) in Fragile and conflict affected situations and Population (in %) in Japan?
Your answer should be compact. 27.93. In the year 1998, what is the difference between the Population (in %) of Fragile and conflict affected situations and Population (in %) of Malaysia?
Offer a terse response. 8.64. In the year 1998, what is the difference between the Population (in %) of Fragile and conflict affected situations and Population (in %) of Poland?
Offer a terse response. 22.02. In the year 1998, what is the difference between the Population (in %) of Japan and Population (in %) of Malaysia?
Provide a short and direct response. -19.29. In the year 1998, what is the difference between the Population (in %) in Japan and Population (in %) in Poland?
Keep it short and to the point. -5.91. In the year 1998, what is the difference between the Population (in %) in Malaysia and Population (in %) in Poland?
Your answer should be compact. 13.37. In the year 1999, what is the difference between the Population (in %) in Fragile and conflict affected situations and Population (in %) in Japan?
Ensure brevity in your answer.  27.99. In the year 1999, what is the difference between the Population (in %) of Fragile and conflict affected situations and Population (in %) of Malaysia?
Offer a terse response. 8.97. In the year 1999, what is the difference between the Population (in %) of Fragile and conflict affected situations and Population (in %) of Poland?
Provide a succinct answer. 22.63. In the year 1999, what is the difference between the Population (in %) of Japan and Population (in %) of Malaysia?
Your response must be concise. -19.02. In the year 1999, what is the difference between the Population (in %) in Japan and Population (in %) in Poland?
Your answer should be compact. -5.36. In the year 1999, what is the difference between the Population (in %) of Malaysia and Population (in %) of Poland?
Provide a succinct answer. 13.66. In the year 2000, what is the difference between the Population (in %) of Fragile and conflict affected situations and Population (in %) of Japan?
Give a very brief answer. 28.02. In the year 2000, what is the difference between the Population (in %) in Fragile and conflict affected situations and Population (in %) in Malaysia?
Offer a very short reply. 8.58. In the year 2000, what is the difference between the Population (in %) of Fragile and conflict affected situations and Population (in %) of Poland?
Your answer should be compact. 23.18. In the year 2000, what is the difference between the Population (in %) in Japan and Population (in %) in Malaysia?
Your answer should be compact. -19.44. In the year 2000, what is the difference between the Population (in %) in Japan and Population (in %) in Poland?
Offer a terse response. -4.84. In the year 2000, what is the difference between the Population (in %) of Malaysia and Population (in %) of Poland?
Ensure brevity in your answer.  14.6. In the year 2001, what is the difference between the Population (in %) of Fragile and conflict affected situations and Population (in %) of Japan?
Your answer should be compact. 28.11. In the year 2001, what is the difference between the Population (in %) in Fragile and conflict affected situations and Population (in %) in Malaysia?
Your response must be concise. 8.95. In the year 2001, what is the difference between the Population (in %) in Fragile and conflict affected situations and Population (in %) in Poland?
Provide a succinct answer. 23.86. In the year 2001, what is the difference between the Population (in %) of Japan and Population (in %) of Malaysia?
Offer a terse response. -19.16. In the year 2001, what is the difference between the Population (in %) of Japan and Population (in %) of Poland?
Your response must be concise. -4.25. In the year 2001, what is the difference between the Population (in %) in Malaysia and Population (in %) in Poland?
Your answer should be compact. 14.91. In the year 2002, what is the difference between the Population (in %) in Fragile and conflict affected situations and Population (in %) in Japan?
Ensure brevity in your answer.  28.17. In the year 2002, what is the difference between the Population (in %) in Fragile and conflict affected situations and Population (in %) in Malaysia?
Offer a very short reply. 9.43. In the year 2002, what is the difference between the Population (in %) in Fragile and conflict affected situations and Population (in %) in Poland?
Provide a short and direct response. 24.42. In the year 2002, what is the difference between the Population (in %) in Japan and Population (in %) in Malaysia?
Your response must be concise. -18.74. In the year 2002, what is the difference between the Population (in %) of Japan and Population (in %) of Poland?
Your answer should be compact. -3.74. In the year 2002, what is the difference between the Population (in %) of Malaysia and Population (in %) of Poland?
Provide a succinct answer. 14.99. What is the ratio of the Population (in %) in Japan in 1995 to that in 1996?
Ensure brevity in your answer.  1.02. What is the ratio of the Population (in %) in Malaysia in 1995 to that in 1996?
Offer a very short reply. 1.01. What is the ratio of the Population (in %) of Poland in 1995 to that in 1996?
Your answer should be very brief. 1.03. What is the ratio of the Population (in %) of Fragile and conflict affected situations in 1995 to that in 1997?
Keep it short and to the point. 1.01. What is the ratio of the Population (in %) in Japan in 1995 to that in 1997?
Provide a succinct answer. 1.04. What is the ratio of the Population (in %) of Malaysia in 1995 to that in 1997?
Offer a terse response. 1.02. What is the ratio of the Population (in %) in Poland in 1995 to that in 1997?
Ensure brevity in your answer.  1.06. What is the ratio of the Population (in %) of Fragile and conflict affected situations in 1995 to that in 1998?
Provide a succinct answer. 1.01. What is the ratio of the Population (in %) of Japan in 1995 to that in 1998?
Offer a terse response. 1.06. What is the ratio of the Population (in %) of Malaysia in 1995 to that in 1998?
Your response must be concise. 1.04. What is the ratio of the Population (in %) of Poland in 1995 to that in 1998?
Provide a short and direct response. 1.1. What is the ratio of the Population (in %) of Fragile and conflict affected situations in 1995 to that in 1999?
Provide a short and direct response. 1.01. What is the ratio of the Population (in %) in Japan in 1995 to that in 1999?
Give a very brief answer. 1.08. What is the ratio of the Population (in %) of Malaysia in 1995 to that in 1999?
Give a very brief answer. 1.05. What is the ratio of the Population (in %) of Poland in 1995 to that in 1999?
Give a very brief answer. 1.14. What is the ratio of the Population (in %) of Fragile and conflict affected situations in 1995 to that in 2000?
Give a very brief answer. 1.02. What is the ratio of the Population (in %) in Japan in 1995 to that in 2000?
Your response must be concise. 1.1. What is the ratio of the Population (in %) in Malaysia in 1995 to that in 2000?
Keep it short and to the point. 1.05. What is the ratio of the Population (in %) of Poland in 1995 to that in 2000?
Your answer should be compact. 1.19. What is the ratio of the Population (in %) of Fragile and conflict affected situations in 1995 to that in 2001?
Your answer should be very brief. 1.02. What is the ratio of the Population (in %) of Japan in 1995 to that in 2001?
Provide a short and direct response. 1.11. What is the ratio of the Population (in %) of Malaysia in 1995 to that in 2001?
Your response must be concise. 1.06. What is the ratio of the Population (in %) in Poland in 1995 to that in 2001?
Provide a succinct answer. 1.24. What is the ratio of the Population (in %) of Fragile and conflict affected situations in 1995 to that in 2002?
Your response must be concise. 1.02. What is the ratio of the Population (in %) of Japan in 1995 to that in 2002?
Ensure brevity in your answer.  1.13. What is the ratio of the Population (in %) of Malaysia in 1995 to that in 2002?
Your answer should be very brief. 1.08. What is the ratio of the Population (in %) in Poland in 1995 to that in 2002?
Your answer should be compact. 1.28. What is the ratio of the Population (in %) of Japan in 1996 to that in 1997?
Give a very brief answer. 1.02. What is the ratio of the Population (in %) of Malaysia in 1996 to that in 1997?
Your answer should be very brief. 1.01. What is the ratio of the Population (in %) in Poland in 1996 to that in 1997?
Your answer should be very brief. 1.03. What is the ratio of the Population (in %) of Fragile and conflict affected situations in 1996 to that in 1998?
Make the answer very short. 1.01. What is the ratio of the Population (in %) in Japan in 1996 to that in 1998?
Provide a succinct answer. 1.04. What is the ratio of the Population (in %) in Malaysia in 1996 to that in 1998?
Make the answer very short. 1.03. What is the ratio of the Population (in %) of Poland in 1996 to that in 1998?
Provide a short and direct response. 1.07. What is the ratio of the Population (in %) of Fragile and conflict affected situations in 1996 to that in 1999?
Your answer should be very brief. 1.01. What is the ratio of the Population (in %) of Japan in 1996 to that in 1999?
Your response must be concise. 1.06. What is the ratio of the Population (in %) of Malaysia in 1996 to that in 1999?
Your answer should be compact. 1.04. What is the ratio of the Population (in %) in Poland in 1996 to that in 1999?
Give a very brief answer. 1.12. What is the ratio of the Population (in %) of Fragile and conflict affected situations in 1996 to that in 2000?
Your answer should be very brief. 1.02. What is the ratio of the Population (in %) of Japan in 1996 to that in 2000?
Offer a terse response. 1.07. What is the ratio of the Population (in %) of Malaysia in 1996 to that in 2000?
Ensure brevity in your answer.  1.04. What is the ratio of the Population (in %) in Poland in 1996 to that in 2000?
Provide a succinct answer. 1.16. What is the ratio of the Population (in %) of Fragile and conflict affected situations in 1996 to that in 2001?
Your response must be concise. 1.02. What is the ratio of the Population (in %) in Japan in 1996 to that in 2001?
Your answer should be very brief. 1.09. What is the ratio of the Population (in %) of Malaysia in 1996 to that in 2001?
Provide a short and direct response. 1.05. What is the ratio of the Population (in %) of Poland in 1996 to that in 2001?
Your response must be concise. 1.21. What is the ratio of the Population (in %) of Fragile and conflict affected situations in 1996 to that in 2002?
Offer a very short reply. 1.02. What is the ratio of the Population (in %) in Japan in 1996 to that in 2002?
Ensure brevity in your answer.  1.1. What is the ratio of the Population (in %) of Malaysia in 1996 to that in 2002?
Ensure brevity in your answer.  1.07. What is the ratio of the Population (in %) of Poland in 1996 to that in 2002?
Your response must be concise. 1.25. What is the ratio of the Population (in %) of Fragile and conflict affected situations in 1997 to that in 1998?
Your answer should be very brief. 1. What is the ratio of the Population (in %) of Japan in 1997 to that in 1998?
Keep it short and to the point. 1.02. What is the ratio of the Population (in %) in Malaysia in 1997 to that in 1998?
Keep it short and to the point. 1.01. What is the ratio of the Population (in %) in Poland in 1997 to that in 1998?
Make the answer very short. 1.04. What is the ratio of the Population (in %) in Fragile and conflict affected situations in 1997 to that in 1999?
Make the answer very short. 1.01. What is the ratio of the Population (in %) in Japan in 1997 to that in 1999?
Your response must be concise. 1.04. What is the ratio of the Population (in %) in Malaysia in 1997 to that in 1999?
Your answer should be very brief. 1.03. What is the ratio of the Population (in %) of Poland in 1997 to that in 1999?
Provide a short and direct response. 1.08. What is the ratio of the Population (in %) of Fragile and conflict affected situations in 1997 to that in 2000?
Make the answer very short. 1.01. What is the ratio of the Population (in %) of Japan in 1997 to that in 2000?
Offer a very short reply. 1.05. What is the ratio of the Population (in %) of Malaysia in 1997 to that in 2000?
Your answer should be very brief. 1.02. What is the ratio of the Population (in %) in Poland in 1997 to that in 2000?
Keep it short and to the point. 1.12. What is the ratio of the Population (in %) of Fragile and conflict affected situations in 1997 to that in 2001?
Provide a succinct answer. 1.02. What is the ratio of the Population (in %) of Japan in 1997 to that in 2001?
Provide a short and direct response. 1.07. What is the ratio of the Population (in %) of Malaysia in 1997 to that in 2001?
Offer a terse response. 1.04. What is the ratio of the Population (in %) of Poland in 1997 to that in 2001?
Your answer should be compact. 1.17. What is the ratio of the Population (in %) in Fragile and conflict affected situations in 1997 to that in 2002?
Your answer should be very brief. 1.02. What is the ratio of the Population (in %) of Japan in 1997 to that in 2002?
Your answer should be compact. 1.08. What is the ratio of the Population (in %) of Malaysia in 1997 to that in 2002?
Your answer should be compact. 1.06. What is the ratio of the Population (in %) in Poland in 1997 to that in 2002?
Provide a short and direct response. 1.21. What is the ratio of the Population (in %) in Fragile and conflict affected situations in 1998 to that in 1999?
Your answer should be compact. 1. What is the ratio of the Population (in %) of Japan in 1998 to that in 1999?
Your response must be concise. 1.02. What is the ratio of the Population (in %) of Malaysia in 1998 to that in 1999?
Your answer should be very brief. 1.02. What is the ratio of the Population (in %) in Poland in 1998 to that in 1999?
Provide a succinct answer. 1.04. What is the ratio of the Population (in %) of Fragile and conflict affected situations in 1998 to that in 2000?
Your answer should be very brief. 1.01. What is the ratio of the Population (in %) in Japan in 1998 to that in 2000?
Ensure brevity in your answer.  1.03. What is the ratio of the Population (in %) of Malaysia in 1998 to that in 2000?
Offer a terse response. 1.01. What is the ratio of the Population (in %) of Poland in 1998 to that in 2000?
Make the answer very short. 1.08. What is the ratio of the Population (in %) of Fragile and conflict affected situations in 1998 to that in 2001?
Your answer should be compact. 1.01. What is the ratio of the Population (in %) in Japan in 1998 to that in 2001?
Give a very brief answer. 1.05. What is the ratio of the Population (in %) of Malaysia in 1998 to that in 2001?
Give a very brief answer. 1.02. What is the ratio of the Population (in %) in Poland in 1998 to that in 2001?
Give a very brief answer. 1.13. What is the ratio of the Population (in %) of Fragile and conflict affected situations in 1998 to that in 2002?
Give a very brief answer. 1.01. What is the ratio of the Population (in %) in Japan in 1998 to that in 2002?
Provide a short and direct response. 1.06. What is the ratio of the Population (in %) of Malaysia in 1998 to that in 2002?
Provide a short and direct response. 1.04. What is the ratio of the Population (in %) in Poland in 1998 to that in 2002?
Make the answer very short. 1.17. What is the ratio of the Population (in %) of Fragile and conflict affected situations in 1999 to that in 2000?
Ensure brevity in your answer.  1. What is the ratio of the Population (in %) in Japan in 1999 to that in 2000?
Your answer should be compact. 1.02. What is the ratio of the Population (in %) in Malaysia in 1999 to that in 2000?
Keep it short and to the point. 0.99. What is the ratio of the Population (in %) of Poland in 1999 to that in 2000?
Provide a succinct answer. 1.04. What is the ratio of the Population (in %) of Fragile and conflict affected situations in 1999 to that in 2001?
Your response must be concise. 1.01. What is the ratio of the Population (in %) in Japan in 1999 to that in 2001?
Offer a very short reply. 1.03. What is the ratio of the Population (in %) of Malaysia in 1999 to that in 2001?
Provide a short and direct response. 1.01. What is the ratio of the Population (in %) in Poland in 1999 to that in 2001?
Your response must be concise. 1.08. What is the ratio of the Population (in %) in Japan in 1999 to that in 2002?
Provide a short and direct response. 1.04. What is the ratio of the Population (in %) in Malaysia in 1999 to that in 2002?
Your answer should be very brief. 1.03. What is the ratio of the Population (in %) of Poland in 1999 to that in 2002?
Provide a short and direct response. 1.12. What is the ratio of the Population (in %) of Fragile and conflict affected situations in 2000 to that in 2001?
Provide a succinct answer. 1. What is the ratio of the Population (in %) of Japan in 2000 to that in 2001?
Ensure brevity in your answer.  1.01. What is the ratio of the Population (in %) in Malaysia in 2000 to that in 2001?
Give a very brief answer. 1.01. What is the ratio of the Population (in %) of Poland in 2000 to that in 2001?
Your answer should be compact. 1.04. What is the ratio of the Population (in %) in Fragile and conflict affected situations in 2000 to that in 2002?
Your answer should be compact. 1.01. What is the ratio of the Population (in %) in Japan in 2000 to that in 2002?
Offer a terse response. 1.03. What is the ratio of the Population (in %) in Malaysia in 2000 to that in 2002?
Offer a terse response. 1.03. What is the ratio of the Population (in %) of Poland in 2000 to that in 2002?
Give a very brief answer. 1.08. What is the ratio of the Population (in %) of Japan in 2001 to that in 2002?
Your answer should be very brief. 1.01. What is the ratio of the Population (in %) of Malaysia in 2001 to that in 2002?
Make the answer very short. 1.02. What is the difference between the highest and the second highest Population (in %) in Fragile and conflict affected situations?
Ensure brevity in your answer.  0.11. What is the difference between the highest and the second highest Population (in %) of Japan?
Your answer should be compact. 0.34. What is the difference between the highest and the second highest Population (in %) in Malaysia?
Your answer should be very brief. 0.38. What is the difference between the highest and the second highest Population (in %) in Poland?
Make the answer very short. 0.57. What is the difference between the highest and the lowest Population (in %) in Fragile and conflict affected situations?
Keep it short and to the point. 1.05. What is the difference between the highest and the lowest Population (in %) of Japan?
Your response must be concise. 1.79. What is the difference between the highest and the lowest Population (in %) in Malaysia?
Offer a terse response. 2.7. What is the difference between the highest and the lowest Population (in %) of Poland?
Offer a very short reply. 5.12. 